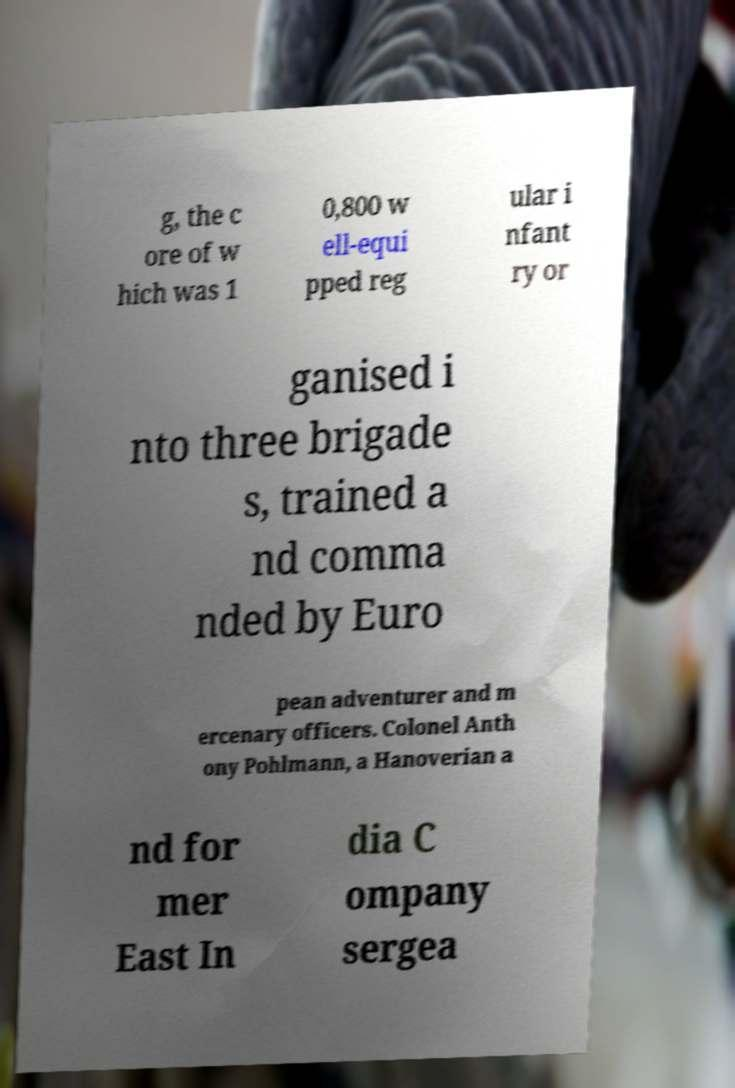Please identify and transcribe the text found in this image. g, the c ore of w hich was 1 0,800 w ell-equi pped reg ular i nfant ry or ganised i nto three brigade s, trained a nd comma nded by Euro pean adventurer and m ercenary officers. Colonel Anth ony Pohlmann, a Hanoverian a nd for mer East In dia C ompany sergea 